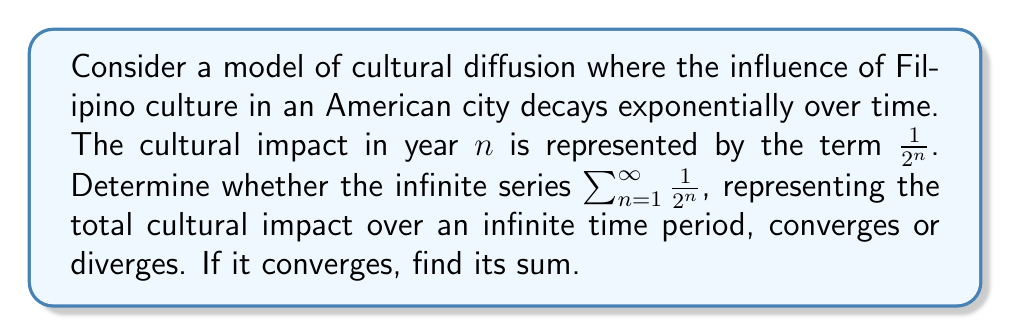What is the answer to this math problem? To determine the convergence of this series, we can use the concept of geometric series.

1) First, let's identify the components of our geometric series:
   - First term, $a = \frac{1}{2}$
   - Common ratio, $r = \frac{1}{2}$

2) For a geometric series $\sum_{n=1}^{\infty} ar^{n-1}$, we know that it converges if $|r| < 1$.

3) In our case, $|r| = |\frac{1}{2}| = \frac{1}{2} < 1$, so the series converges.

4) For a convergent geometric series, the sum is given by the formula:

   $$S_{\infty} = \frac{a}{1-r}$$

   where $a$ is the first term and $r$ is the common ratio.

5) Substituting our values:

   $$S_{\infty} = \frac{\frac{1}{2}}{1-\frac{1}{2}} = \frac{\frac{1}{2}}{\frac{1}{2}} = 1$$

Therefore, the series converges and its sum is 1.

In the context of cultural diffusion, this means that while the Filipino cultural influence decreases over time, its cumulative impact over an infinite period is finite and equal to 1 unit of cultural influence.
Answer: The series $\sum_{n=1}^{\infty} \frac{1}{2^n}$ converges, and its sum is 1. 